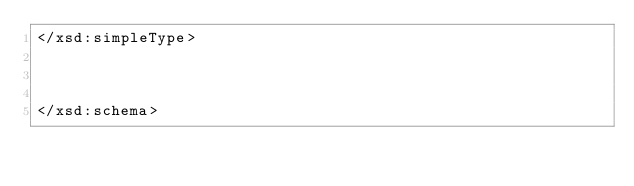<code> <loc_0><loc_0><loc_500><loc_500><_XML_></xsd:simpleType>



</xsd:schema>
</code> 